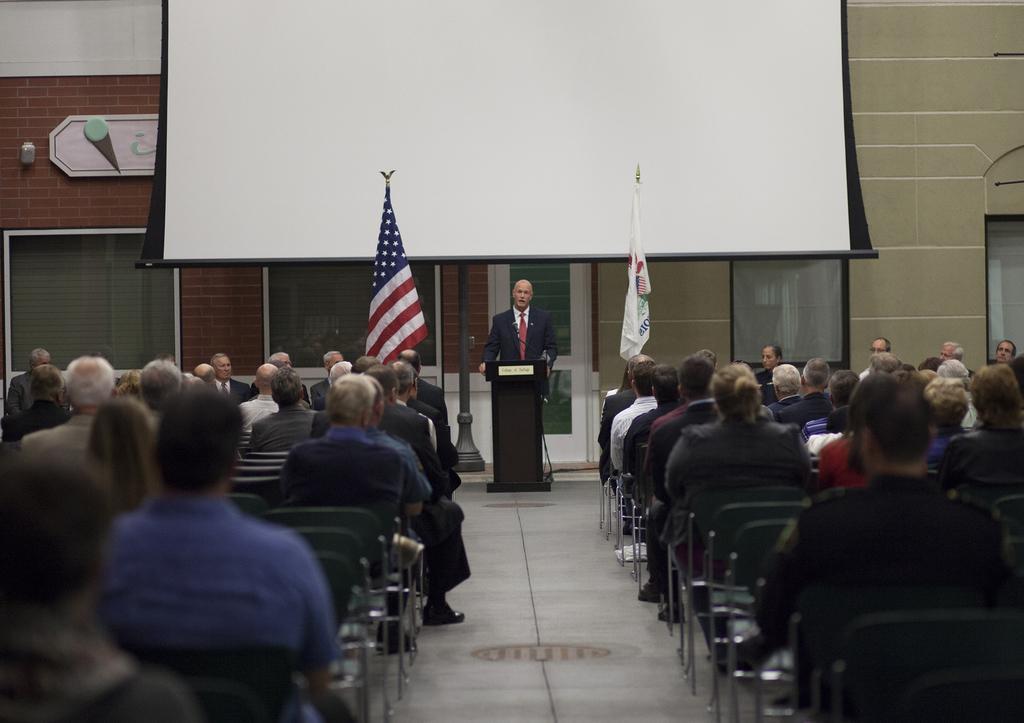Can you describe this image briefly? In the picture we can see group of people sitting on chairs and in the background of the picture there is a person wearing suit standing behind wooden podium, there are flags and we can see projector screen and there is a wall. 